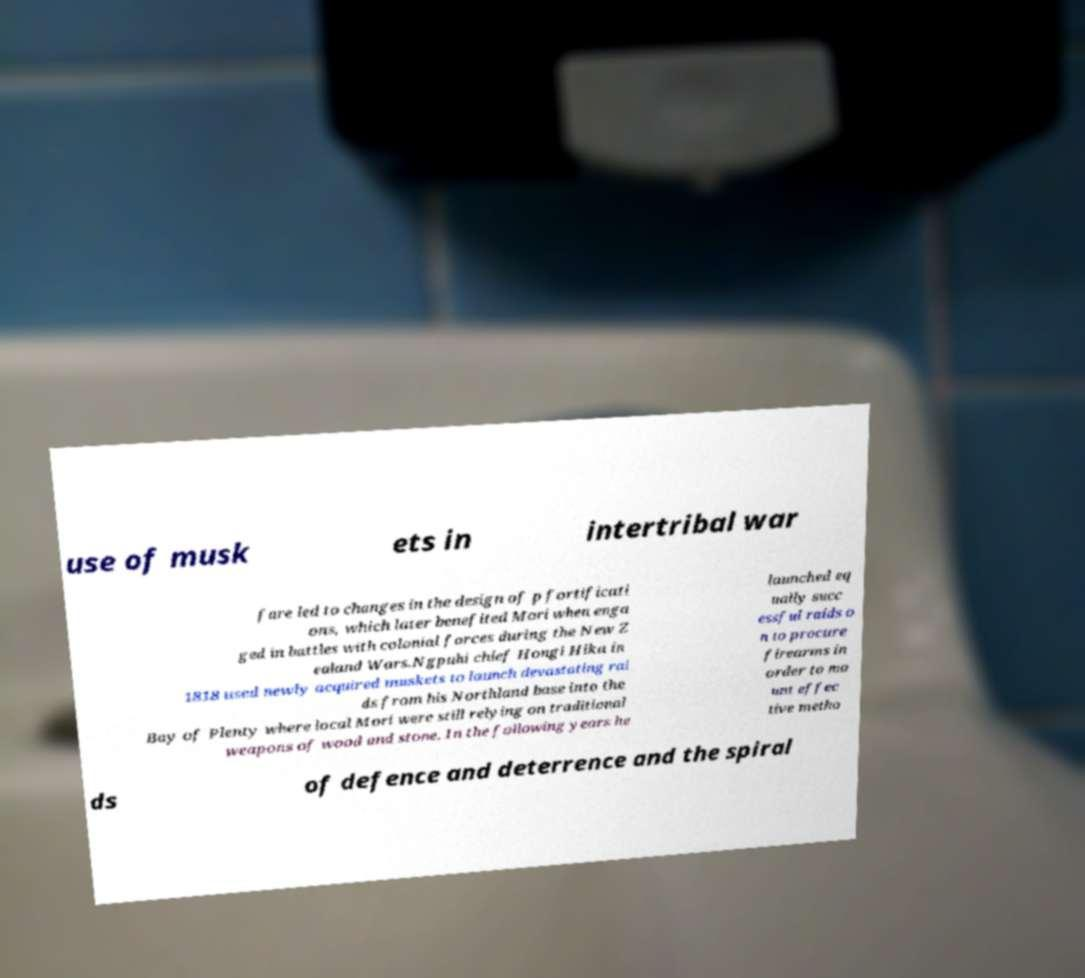Can you read and provide the text displayed in the image?This photo seems to have some interesting text. Can you extract and type it out for me? use of musk ets in intertribal war fare led to changes in the design of p fortificati ons, which later benefited Mori when enga ged in battles with colonial forces during the New Z ealand Wars.Ngpuhi chief Hongi Hika in 1818 used newly acquired muskets to launch devastating rai ds from his Northland base into the Bay of Plenty where local Mori were still relying on traditional weapons of wood and stone. In the following years he launched eq ually succ essful raids o n to procure firearms in order to mo unt effec tive metho ds of defence and deterrence and the spiral 